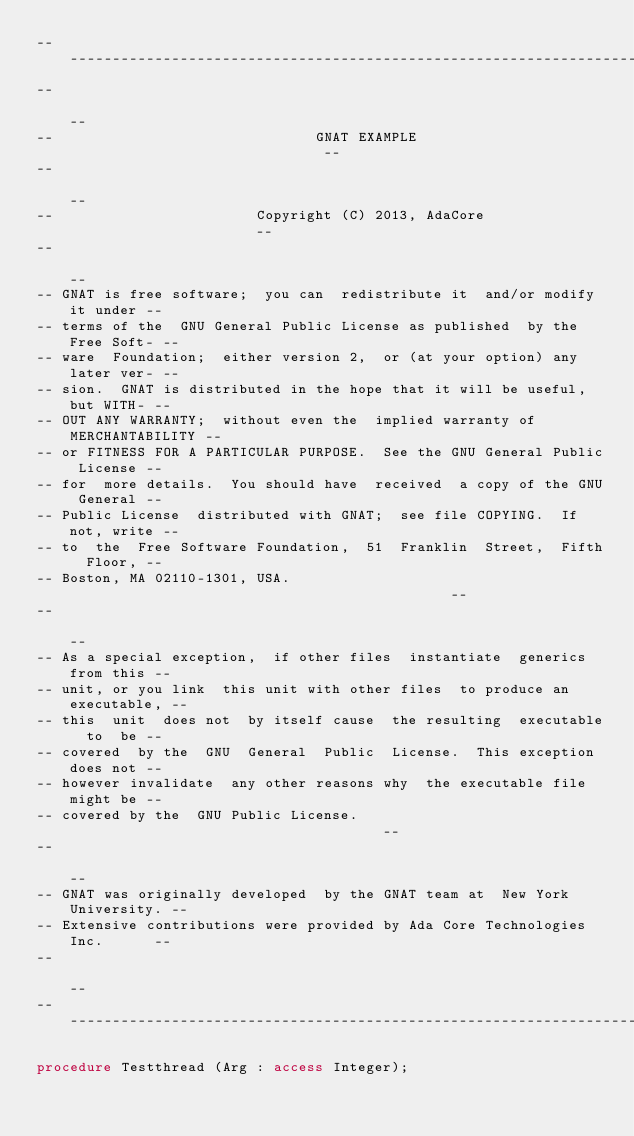Convert code to text. <code><loc_0><loc_0><loc_500><loc_500><_Ada_>------------------------------------------------------------------------------
--                                                                          --
--                               GNAT EXAMPLE                               --
--                                                                          --
--                        Copyright (C) 2013, AdaCore                       --
--                                                                          --
-- GNAT is free software;  you can  redistribute it  and/or modify it under --
-- terms of the  GNU General Public License as published  by the Free Soft- --
-- ware  Foundation;  either version 2,  or (at your option) any later ver- --
-- sion.  GNAT is distributed in the hope that it will be useful, but WITH- --
-- OUT ANY WARRANTY;  without even the  implied warranty of MERCHANTABILITY --
-- or FITNESS FOR A PARTICULAR PURPOSE.  See the GNU General Public License --
-- for  more details.  You should have  received  a copy of the GNU General --
-- Public License  distributed with GNAT;  see file COPYING.  If not, write --
-- to  the  Free Software Foundation,  51  Franklin  Street,  Fifth  Floor, --
-- Boston, MA 02110-1301, USA.                                              --
--                                                                          --
-- As a special exception,  if other files  instantiate  generics from this --
-- unit, or you link  this unit with other files  to produce an executable, --
-- this  unit  does not  by itself cause  the resulting  executable  to  be --
-- covered  by the  GNU  General  Public  License.  This exception does not --
-- however invalidate  any other reasons why  the executable file  might be --
-- covered by the  GNU Public License.                                      --
--                                                                          --
-- GNAT was originally developed  by the GNAT team at  New York University. --
-- Extensive contributions were provided by Ada Core Technologies Inc.      --
--                                                                          --
------------------------------------------------------------------------------

procedure Testthread (Arg : access Integer);
</code> 